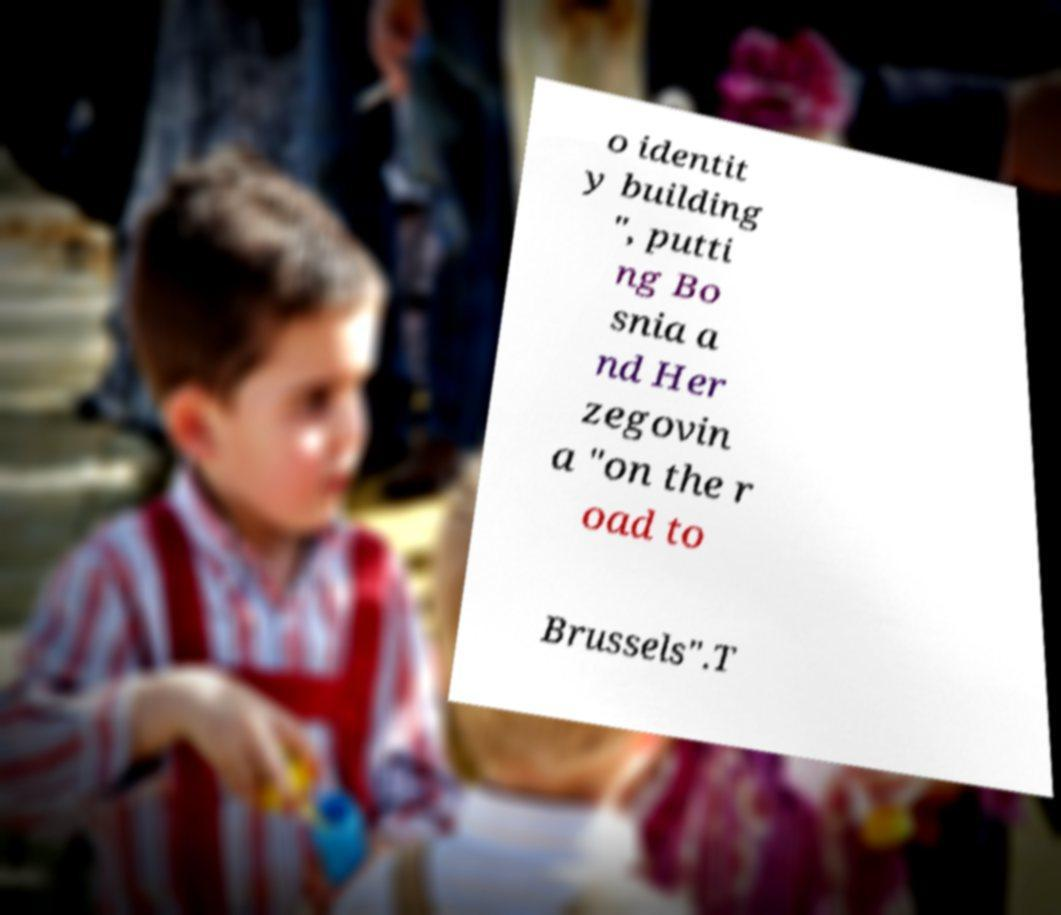Can you read and provide the text displayed in the image?This photo seems to have some interesting text. Can you extract and type it out for me? o identit y building ", putti ng Bo snia a nd Her zegovin a "on the r oad to Brussels".T 